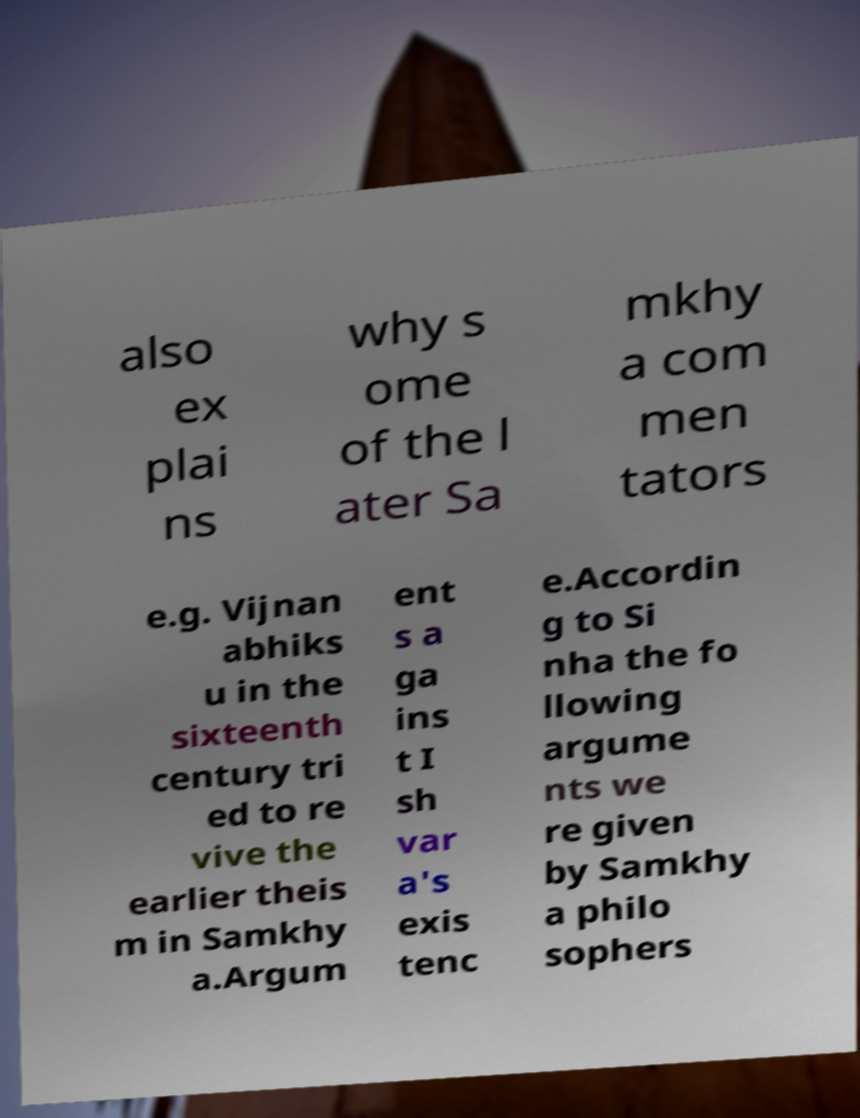Could you extract and type out the text from this image? also ex plai ns why s ome of the l ater Sa mkhy a com men tators e.g. Vijnan abhiks u in the sixteenth century tri ed to re vive the earlier theis m in Samkhy a.Argum ent s a ga ins t I sh var a's exis tenc e.Accordin g to Si nha the fo llowing argume nts we re given by Samkhy a philo sophers 